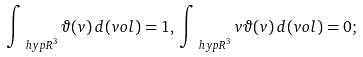<formula> <loc_0><loc_0><loc_500><loc_500>\int _ { { \ h y p R } ^ { 3 } } { \vartheta } ( v ) \, d ( v o l ) = 1 , \, \int _ { { \ h y p R } ^ { 3 } } { v \vartheta } ( v ) \, d ( v o l ) = 0 ;</formula> 